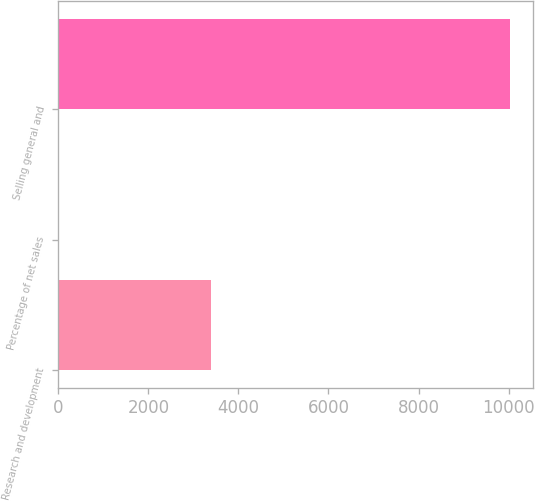Convert chart. <chart><loc_0><loc_0><loc_500><loc_500><bar_chart><fcel>Research and development<fcel>Percentage of net sales<fcel>Selling general and<nl><fcel>3381<fcel>2<fcel>10040<nl></chart> 